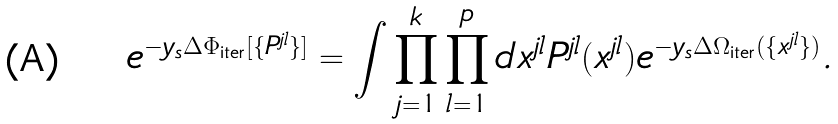<formula> <loc_0><loc_0><loc_500><loc_500>e ^ { - y _ { s } \Delta \Phi _ { \text {iter} } [ \{ P ^ { j l } \} ] } = \int \prod _ { j = 1 } ^ { k } \prod _ { l = 1 } ^ { p } d x ^ { j l } P ^ { j l } ( x ^ { j l } ) e ^ { - y _ { s } \Delta \Omega _ { \text {iter} } ( \{ x ^ { j l } \} ) } .</formula> 